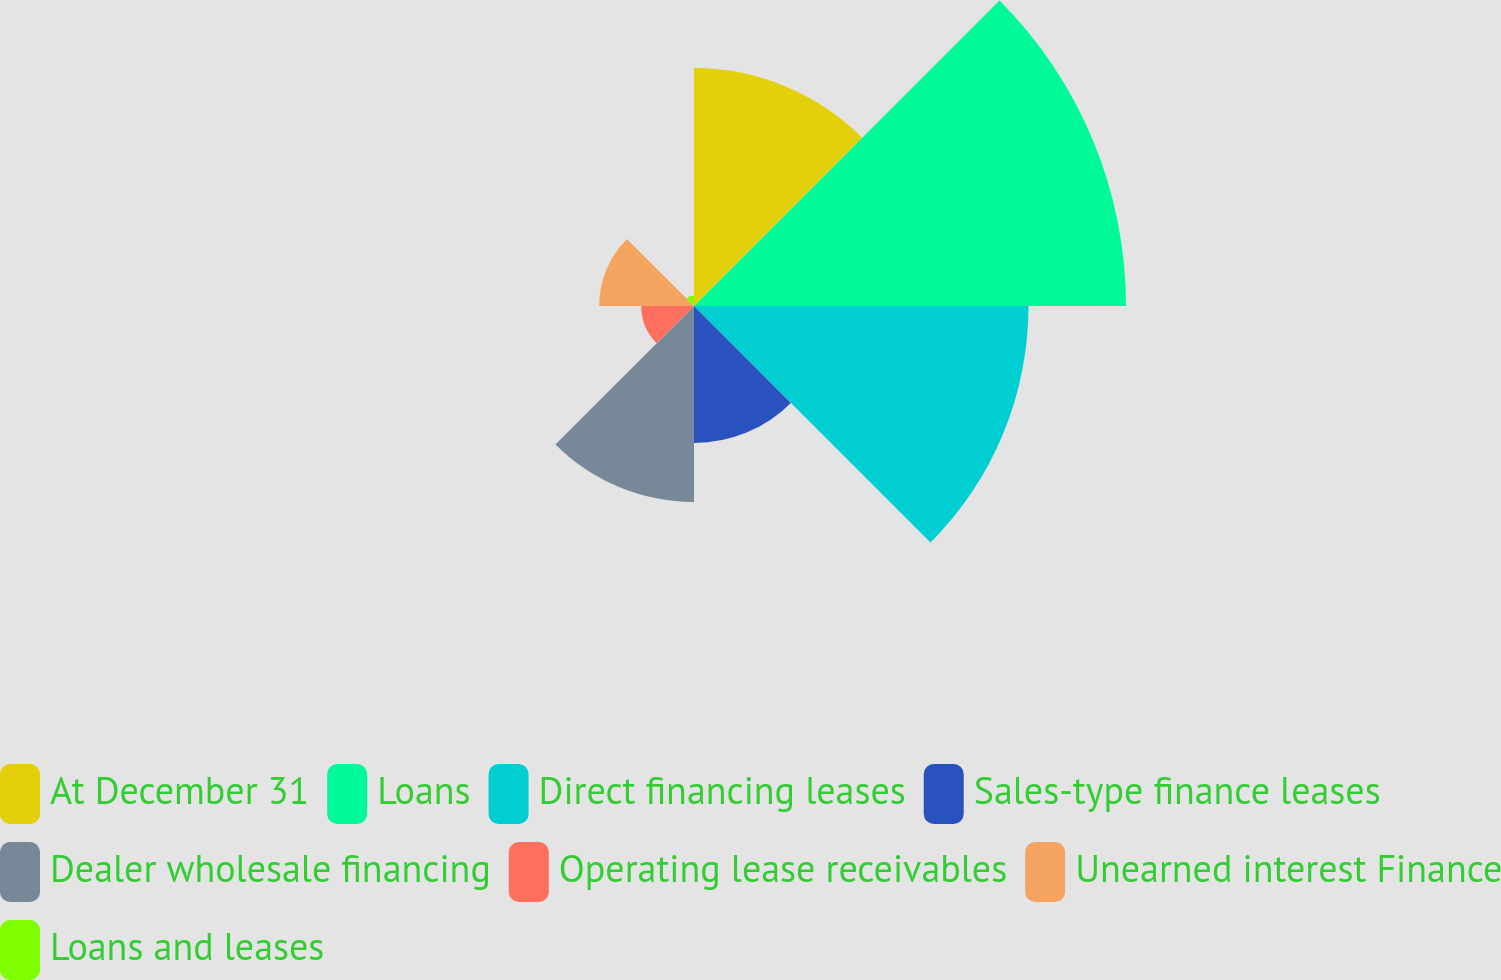<chart> <loc_0><loc_0><loc_500><loc_500><pie_chart><fcel>At December 31<fcel>Loans<fcel>Direct financing leases<fcel>Sales-type finance leases<fcel>Dealer wholesale financing<fcel>Operating lease receivables<fcel>Unearned interest Finance<fcel>Loans and leases<nl><fcel>15.91%<fcel>28.88%<fcel>22.36%<fcel>9.16%<fcel>13.1%<fcel>3.53%<fcel>6.34%<fcel>0.71%<nl></chart> 